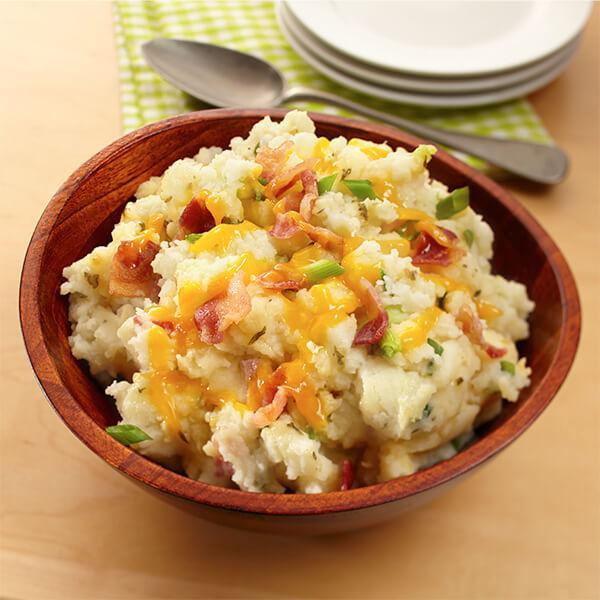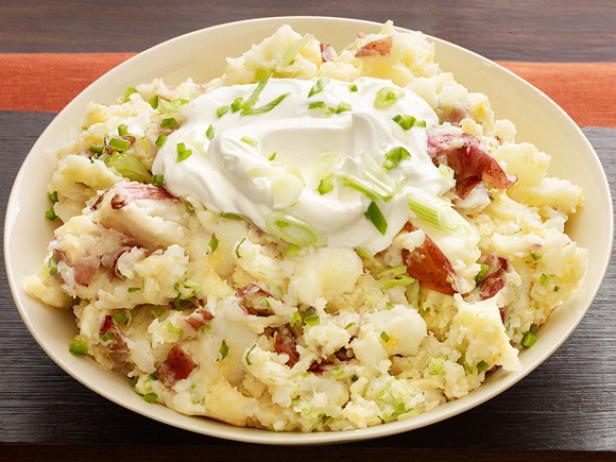The first image is the image on the left, the second image is the image on the right. For the images shown, is this caption "A spoon is near a round brown bowl of garnished mashed potatoes in the left image." true? Answer yes or no. Yes. The first image is the image on the left, the second image is the image on the right. For the images shown, is this caption "The left and right image contains the same number of bowls of mash potatoes with at least one wooden bowl." true? Answer yes or no. Yes. 